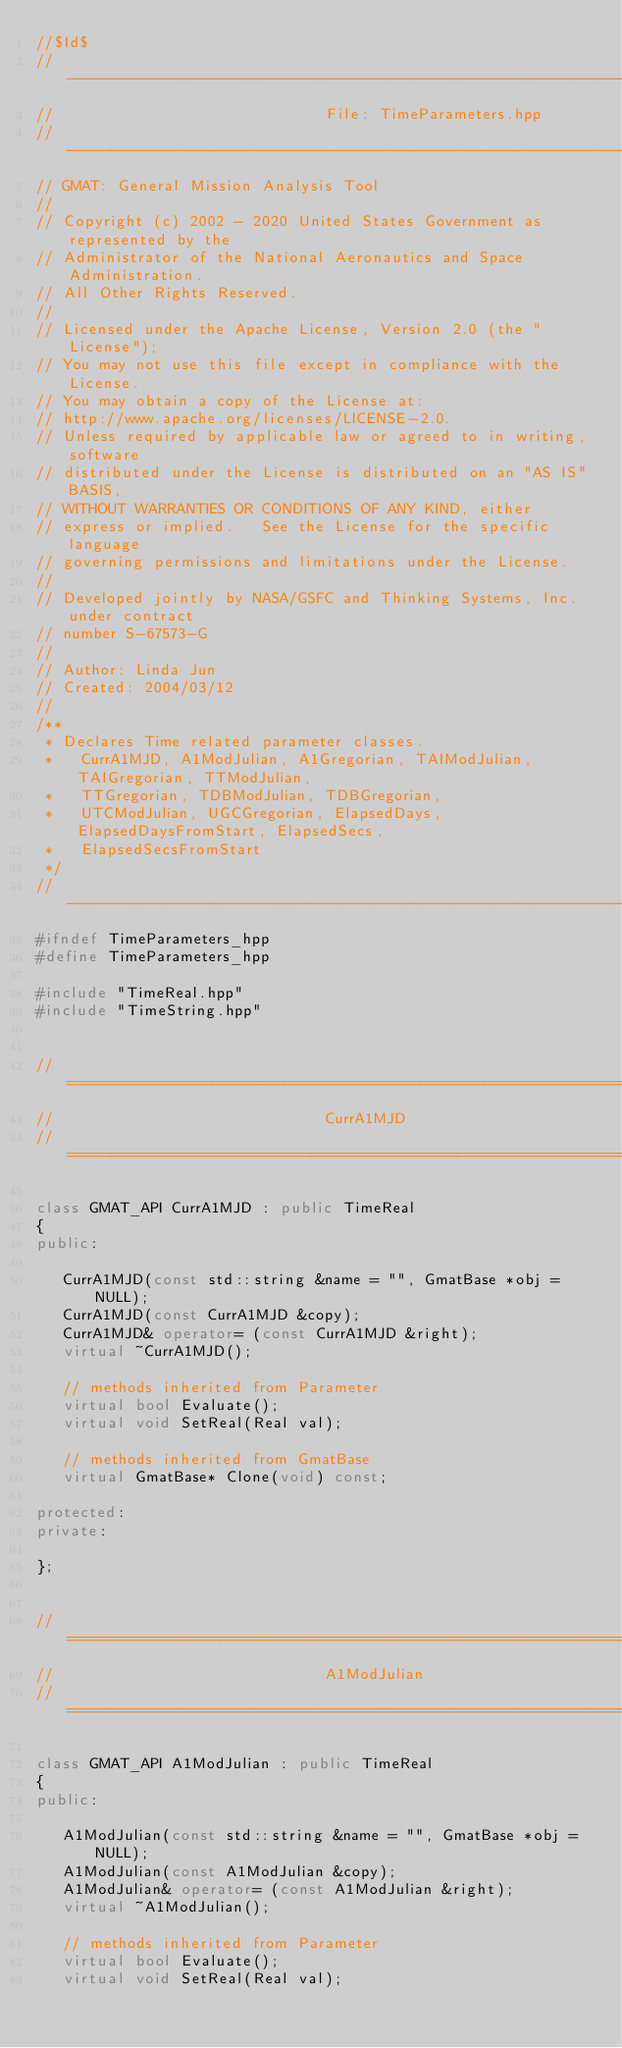Convert code to text. <code><loc_0><loc_0><loc_500><loc_500><_C++_>//$Id$
//------------------------------------------------------------------------------
//                              File: TimeParameters.hpp
//------------------------------------------------------------------------------
// GMAT: General Mission Analysis Tool
//
// Copyright (c) 2002 - 2020 United States Government as represented by the
// Administrator of the National Aeronautics and Space Administration.
// All Other Rights Reserved.
//
// Licensed under the Apache License, Version 2.0 (the "License"); 
// You may not use this file except in compliance with the License. 
// You may obtain a copy of the License at:
// http://www.apache.org/licenses/LICENSE-2.0. 
// Unless required by applicable law or agreed to in writing, software
// distributed under the License is distributed on an "AS IS" BASIS,
// WITHOUT WARRANTIES OR CONDITIONS OF ANY KIND, either 
// express or implied.   See the License for the specific language
// governing permissions and limitations under the License.
//
// Developed jointly by NASA/GSFC and Thinking Systems, Inc. under contract
// number S-67573-G
//
// Author: Linda Jun
// Created: 2004/03/12
//
/**
 * Declares Time related parameter classes.
 *   CurrA1MJD, A1ModJulian, A1Gregorian, TAIModJulian, TAIGregorian, TTModJulian,
 *   TTGregorian, TDBModJulian, TDBGregorian,
 *   UTCModJulian, UGCGregorian, ElapsedDays, ElapsedDaysFromStart, ElapsedSecs,
 *   ElapsedSecsFromStart
 */
//------------------------------------------------------------------------------
#ifndef TimeParameters_hpp
#define TimeParameters_hpp

#include "TimeReal.hpp"
#include "TimeString.hpp"


//==============================================================================
//                              CurrA1MJD
//==============================================================================

class GMAT_API CurrA1MJD : public TimeReal
{
public:

   CurrA1MJD(const std::string &name = "", GmatBase *obj = NULL);
   CurrA1MJD(const CurrA1MJD &copy);
   CurrA1MJD& operator= (const CurrA1MJD &right); 
   virtual ~CurrA1MJD();
   
   // methods inherited from Parameter
   virtual bool Evaluate();
   virtual void SetReal(Real val);
   
   // methods inherited from GmatBase
   virtual GmatBase* Clone(void) const;
   
protected:
private:

};


//==============================================================================
//                              A1ModJulian
//==============================================================================

class GMAT_API A1ModJulian : public TimeReal
{
public:

   A1ModJulian(const std::string &name = "", GmatBase *obj = NULL);
   A1ModJulian(const A1ModJulian &copy);
   A1ModJulian& operator= (const A1ModJulian &right); 
   virtual ~A1ModJulian();

   // methods inherited from Parameter
   virtual bool Evaluate();
   virtual void SetReal(Real val);
   </code> 